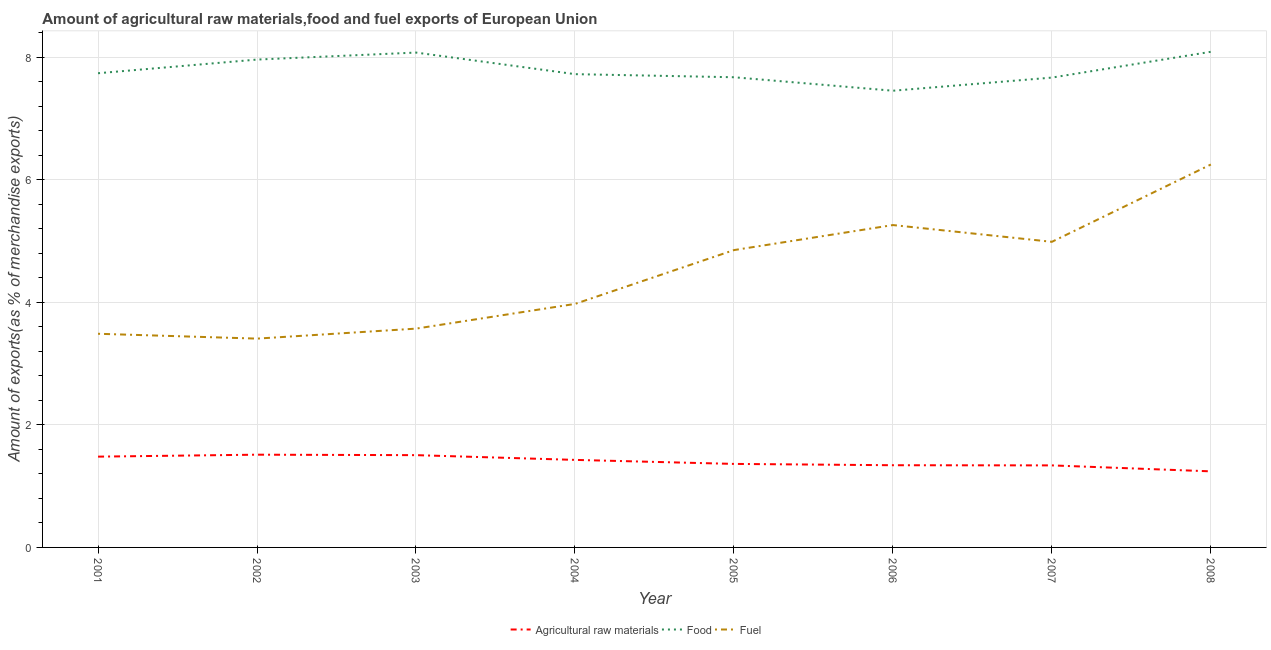Does the line corresponding to percentage of raw materials exports intersect with the line corresponding to percentage of fuel exports?
Give a very brief answer. No. Is the number of lines equal to the number of legend labels?
Offer a terse response. Yes. What is the percentage of fuel exports in 2002?
Provide a succinct answer. 3.41. Across all years, what is the maximum percentage of food exports?
Your response must be concise. 8.09. Across all years, what is the minimum percentage of food exports?
Make the answer very short. 7.45. In which year was the percentage of raw materials exports maximum?
Your answer should be compact. 2002. In which year was the percentage of raw materials exports minimum?
Ensure brevity in your answer.  2008. What is the total percentage of food exports in the graph?
Provide a succinct answer. 62.36. What is the difference between the percentage of raw materials exports in 2002 and that in 2003?
Make the answer very short. 0.01. What is the difference between the percentage of food exports in 2008 and the percentage of raw materials exports in 2006?
Offer a terse response. 6.74. What is the average percentage of raw materials exports per year?
Provide a short and direct response. 1.4. In the year 2006, what is the difference between the percentage of food exports and percentage of raw materials exports?
Your response must be concise. 6.11. In how many years, is the percentage of food exports greater than 3.2 %?
Offer a terse response. 8. What is the ratio of the percentage of fuel exports in 2002 to that in 2005?
Your answer should be very brief. 0.7. What is the difference between the highest and the second highest percentage of food exports?
Your answer should be very brief. 0.01. What is the difference between the highest and the lowest percentage of fuel exports?
Keep it short and to the point. 2.84. Does the percentage of food exports monotonically increase over the years?
Your answer should be very brief. No. Is the percentage of raw materials exports strictly less than the percentage of fuel exports over the years?
Offer a very short reply. Yes. Are the values on the major ticks of Y-axis written in scientific E-notation?
Offer a terse response. No. Does the graph contain grids?
Provide a succinct answer. Yes. Where does the legend appear in the graph?
Provide a succinct answer. Bottom center. How many legend labels are there?
Offer a terse response. 3. What is the title of the graph?
Offer a very short reply. Amount of agricultural raw materials,food and fuel exports of European Union. What is the label or title of the X-axis?
Your answer should be compact. Year. What is the label or title of the Y-axis?
Offer a very short reply. Amount of exports(as % of merchandise exports). What is the Amount of exports(as % of merchandise exports) of Agricultural raw materials in 2001?
Give a very brief answer. 1.48. What is the Amount of exports(as % of merchandise exports) of Food in 2001?
Make the answer very short. 7.74. What is the Amount of exports(as % of merchandise exports) in Fuel in 2001?
Offer a very short reply. 3.49. What is the Amount of exports(as % of merchandise exports) of Agricultural raw materials in 2002?
Give a very brief answer. 1.51. What is the Amount of exports(as % of merchandise exports) of Food in 2002?
Give a very brief answer. 7.96. What is the Amount of exports(as % of merchandise exports) of Fuel in 2002?
Your response must be concise. 3.41. What is the Amount of exports(as % of merchandise exports) in Agricultural raw materials in 2003?
Provide a succinct answer. 1.51. What is the Amount of exports(as % of merchandise exports) in Food in 2003?
Ensure brevity in your answer.  8.07. What is the Amount of exports(as % of merchandise exports) of Fuel in 2003?
Provide a succinct answer. 3.57. What is the Amount of exports(as % of merchandise exports) of Agricultural raw materials in 2004?
Keep it short and to the point. 1.43. What is the Amount of exports(as % of merchandise exports) of Food in 2004?
Keep it short and to the point. 7.72. What is the Amount of exports(as % of merchandise exports) in Fuel in 2004?
Offer a very short reply. 3.97. What is the Amount of exports(as % of merchandise exports) of Agricultural raw materials in 2005?
Give a very brief answer. 1.36. What is the Amount of exports(as % of merchandise exports) in Food in 2005?
Give a very brief answer. 7.67. What is the Amount of exports(as % of merchandise exports) in Fuel in 2005?
Offer a terse response. 4.85. What is the Amount of exports(as % of merchandise exports) of Agricultural raw materials in 2006?
Provide a succinct answer. 1.34. What is the Amount of exports(as % of merchandise exports) in Food in 2006?
Make the answer very short. 7.45. What is the Amount of exports(as % of merchandise exports) in Fuel in 2006?
Offer a very short reply. 5.26. What is the Amount of exports(as % of merchandise exports) in Agricultural raw materials in 2007?
Provide a short and direct response. 1.34. What is the Amount of exports(as % of merchandise exports) of Food in 2007?
Give a very brief answer. 7.66. What is the Amount of exports(as % of merchandise exports) in Fuel in 2007?
Offer a terse response. 4.99. What is the Amount of exports(as % of merchandise exports) of Agricultural raw materials in 2008?
Your response must be concise. 1.24. What is the Amount of exports(as % of merchandise exports) of Food in 2008?
Your response must be concise. 8.09. What is the Amount of exports(as % of merchandise exports) of Fuel in 2008?
Ensure brevity in your answer.  6.25. Across all years, what is the maximum Amount of exports(as % of merchandise exports) of Agricultural raw materials?
Your response must be concise. 1.51. Across all years, what is the maximum Amount of exports(as % of merchandise exports) of Food?
Provide a short and direct response. 8.09. Across all years, what is the maximum Amount of exports(as % of merchandise exports) of Fuel?
Offer a terse response. 6.25. Across all years, what is the minimum Amount of exports(as % of merchandise exports) of Agricultural raw materials?
Provide a short and direct response. 1.24. Across all years, what is the minimum Amount of exports(as % of merchandise exports) of Food?
Keep it short and to the point. 7.45. Across all years, what is the minimum Amount of exports(as % of merchandise exports) in Fuel?
Ensure brevity in your answer.  3.41. What is the total Amount of exports(as % of merchandise exports) of Agricultural raw materials in the graph?
Your answer should be compact. 11.21. What is the total Amount of exports(as % of merchandise exports) in Food in the graph?
Provide a succinct answer. 62.36. What is the total Amount of exports(as % of merchandise exports) in Fuel in the graph?
Give a very brief answer. 35.78. What is the difference between the Amount of exports(as % of merchandise exports) of Agricultural raw materials in 2001 and that in 2002?
Provide a succinct answer. -0.03. What is the difference between the Amount of exports(as % of merchandise exports) in Food in 2001 and that in 2002?
Offer a very short reply. -0.22. What is the difference between the Amount of exports(as % of merchandise exports) of Fuel in 2001 and that in 2002?
Provide a succinct answer. 0.08. What is the difference between the Amount of exports(as % of merchandise exports) of Agricultural raw materials in 2001 and that in 2003?
Offer a very short reply. -0.02. What is the difference between the Amount of exports(as % of merchandise exports) in Food in 2001 and that in 2003?
Offer a very short reply. -0.34. What is the difference between the Amount of exports(as % of merchandise exports) of Fuel in 2001 and that in 2003?
Keep it short and to the point. -0.08. What is the difference between the Amount of exports(as % of merchandise exports) of Agricultural raw materials in 2001 and that in 2004?
Keep it short and to the point. 0.05. What is the difference between the Amount of exports(as % of merchandise exports) in Food in 2001 and that in 2004?
Your answer should be compact. 0.01. What is the difference between the Amount of exports(as % of merchandise exports) in Fuel in 2001 and that in 2004?
Ensure brevity in your answer.  -0.49. What is the difference between the Amount of exports(as % of merchandise exports) in Agricultural raw materials in 2001 and that in 2005?
Provide a short and direct response. 0.12. What is the difference between the Amount of exports(as % of merchandise exports) in Food in 2001 and that in 2005?
Provide a succinct answer. 0.07. What is the difference between the Amount of exports(as % of merchandise exports) in Fuel in 2001 and that in 2005?
Offer a very short reply. -1.36. What is the difference between the Amount of exports(as % of merchandise exports) of Agricultural raw materials in 2001 and that in 2006?
Provide a short and direct response. 0.14. What is the difference between the Amount of exports(as % of merchandise exports) of Food in 2001 and that in 2006?
Provide a succinct answer. 0.29. What is the difference between the Amount of exports(as % of merchandise exports) in Fuel in 2001 and that in 2006?
Offer a terse response. -1.77. What is the difference between the Amount of exports(as % of merchandise exports) in Agricultural raw materials in 2001 and that in 2007?
Offer a very short reply. 0.14. What is the difference between the Amount of exports(as % of merchandise exports) in Food in 2001 and that in 2007?
Offer a terse response. 0.07. What is the difference between the Amount of exports(as % of merchandise exports) in Fuel in 2001 and that in 2007?
Provide a succinct answer. -1.5. What is the difference between the Amount of exports(as % of merchandise exports) in Agricultural raw materials in 2001 and that in 2008?
Offer a terse response. 0.24. What is the difference between the Amount of exports(as % of merchandise exports) in Food in 2001 and that in 2008?
Offer a terse response. -0.35. What is the difference between the Amount of exports(as % of merchandise exports) in Fuel in 2001 and that in 2008?
Your response must be concise. -2.76. What is the difference between the Amount of exports(as % of merchandise exports) in Agricultural raw materials in 2002 and that in 2003?
Ensure brevity in your answer.  0.01. What is the difference between the Amount of exports(as % of merchandise exports) of Food in 2002 and that in 2003?
Your answer should be very brief. -0.11. What is the difference between the Amount of exports(as % of merchandise exports) of Fuel in 2002 and that in 2003?
Your answer should be very brief. -0.16. What is the difference between the Amount of exports(as % of merchandise exports) of Agricultural raw materials in 2002 and that in 2004?
Ensure brevity in your answer.  0.08. What is the difference between the Amount of exports(as % of merchandise exports) in Food in 2002 and that in 2004?
Offer a terse response. 0.24. What is the difference between the Amount of exports(as % of merchandise exports) in Fuel in 2002 and that in 2004?
Your response must be concise. -0.57. What is the difference between the Amount of exports(as % of merchandise exports) of Agricultural raw materials in 2002 and that in 2005?
Make the answer very short. 0.15. What is the difference between the Amount of exports(as % of merchandise exports) in Food in 2002 and that in 2005?
Your answer should be very brief. 0.29. What is the difference between the Amount of exports(as % of merchandise exports) in Fuel in 2002 and that in 2005?
Your answer should be very brief. -1.44. What is the difference between the Amount of exports(as % of merchandise exports) in Agricultural raw materials in 2002 and that in 2006?
Your response must be concise. 0.17. What is the difference between the Amount of exports(as % of merchandise exports) in Food in 2002 and that in 2006?
Your response must be concise. 0.51. What is the difference between the Amount of exports(as % of merchandise exports) of Fuel in 2002 and that in 2006?
Your response must be concise. -1.85. What is the difference between the Amount of exports(as % of merchandise exports) in Agricultural raw materials in 2002 and that in 2007?
Your response must be concise. 0.17. What is the difference between the Amount of exports(as % of merchandise exports) in Food in 2002 and that in 2007?
Provide a short and direct response. 0.29. What is the difference between the Amount of exports(as % of merchandise exports) of Fuel in 2002 and that in 2007?
Offer a terse response. -1.58. What is the difference between the Amount of exports(as % of merchandise exports) in Agricultural raw materials in 2002 and that in 2008?
Your response must be concise. 0.27. What is the difference between the Amount of exports(as % of merchandise exports) of Food in 2002 and that in 2008?
Make the answer very short. -0.13. What is the difference between the Amount of exports(as % of merchandise exports) of Fuel in 2002 and that in 2008?
Give a very brief answer. -2.84. What is the difference between the Amount of exports(as % of merchandise exports) in Agricultural raw materials in 2003 and that in 2004?
Your response must be concise. 0.08. What is the difference between the Amount of exports(as % of merchandise exports) in Food in 2003 and that in 2004?
Offer a terse response. 0.35. What is the difference between the Amount of exports(as % of merchandise exports) in Fuel in 2003 and that in 2004?
Offer a very short reply. -0.4. What is the difference between the Amount of exports(as % of merchandise exports) of Agricultural raw materials in 2003 and that in 2005?
Ensure brevity in your answer.  0.14. What is the difference between the Amount of exports(as % of merchandise exports) of Food in 2003 and that in 2005?
Your response must be concise. 0.4. What is the difference between the Amount of exports(as % of merchandise exports) in Fuel in 2003 and that in 2005?
Make the answer very short. -1.28. What is the difference between the Amount of exports(as % of merchandise exports) in Agricultural raw materials in 2003 and that in 2006?
Your response must be concise. 0.16. What is the difference between the Amount of exports(as % of merchandise exports) in Food in 2003 and that in 2006?
Provide a succinct answer. 0.62. What is the difference between the Amount of exports(as % of merchandise exports) in Fuel in 2003 and that in 2006?
Offer a very short reply. -1.69. What is the difference between the Amount of exports(as % of merchandise exports) in Agricultural raw materials in 2003 and that in 2007?
Provide a short and direct response. 0.17. What is the difference between the Amount of exports(as % of merchandise exports) of Food in 2003 and that in 2007?
Offer a terse response. 0.41. What is the difference between the Amount of exports(as % of merchandise exports) in Fuel in 2003 and that in 2007?
Provide a succinct answer. -1.42. What is the difference between the Amount of exports(as % of merchandise exports) of Agricultural raw materials in 2003 and that in 2008?
Make the answer very short. 0.26. What is the difference between the Amount of exports(as % of merchandise exports) in Food in 2003 and that in 2008?
Ensure brevity in your answer.  -0.01. What is the difference between the Amount of exports(as % of merchandise exports) of Fuel in 2003 and that in 2008?
Your answer should be compact. -2.68. What is the difference between the Amount of exports(as % of merchandise exports) of Agricultural raw materials in 2004 and that in 2005?
Give a very brief answer. 0.07. What is the difference between the Amount of exports(as % of merchandise exports) of Food in 2004 and that in 2005?
Give a very brief answer. 0.05. What is the difference between the Amount of exports(as % of merchandise exports) of Fuel in 2004 and that in 2005?
Offer a very short reply. -0.88. What is the difference between the Amount of exports(as % of merchandise exports) in Agricultural raw materials in 2004 and that in 2006?
Your response must be concise. 0.09. What is the difference between the Amount of exports(as % of merchandise exports) in Food in 2004 and that in 2006?
Make the answer very short. 0.27. What is the difference between the Amount of exports(as % of merchandise exports) of Fuel in 2004 and that in 2006?
Offer a terse response. -1.29. What is the difference between the Amount of exports(as % of merchandise exports) in Agricultural raw materials in 2004 and that in 2007?
Ensure brevity in your answer.  0.09. What is the difference between the Amount of exports(as % of merchandise exports) in Food in 2004 and that in 2007?
Offer a terse response. 0.06. What is the difference between the Amount of exports(as % of merchandise exports) in Fuel in 2004 and that in 2007?
Ensure brevity in your answer.  -1.01. What is the difference between the Amount of exports(as % of merchandise exports) of Agricultural raw materials in 2004 and that in 2008?
Make the answer very short. 0.19. What is the difference between the Amount of exports(as % of merchandise exports) of Food in 2004 and that in 2008?
Make the answer very short. -0.36. What is the difference between the Amount of exports(as % of merchandise exports) of Fuel in 2004 and that in 2008?
Your answer should be very brief. -2.27. What is the difference between the Amount of exports(as % of merchandise exports) in Agricultural raw materials in 2005 and that in 2006?
Ensure brevity in your answer.  0.02. What is the difference between the Amount of exports(as % of merchandise exports) of Food in 2005 and that in 2006?
Keep it short and to the point. 0.22. What is the difference between the Amount of exports(as % of merchandise exports) of Fuel in 2005 and that in 2006?
Your answer should be very brief. -0.41. What is the difference between the Amount of exports(as % of merchandise exports) in Agricultural raw materials in 2005 and that in 2007?
Ensure brevity in your answer.  0.02. What is the difference between the Amount of exports(as % of merchandise exports) of Food in 2005 and that in 2007?
Give a very brief answer. 0.01. What is the difference between the Amount of exports(as % of merchandise exports) in Fuel in 2005 and that in 2007?
Offer a very short reply. -0.14. What is the difference between the Amount of exports(as % of merchandise exports) in Agricultural raw materials in 2005 and that in 2008?
Offer a terse response. 0.12. What is the difference between the Amount of exports(as % of merchandise exports) in Food in 2005 and that in 2008?
Make the answer very short. -0.42. What is the difference between the Amount of exports(as % of merchandise exports) of Fuel in 2005 and that in 2008?
Your answer should be very brief. -1.4. What is the difference between the Amount of exports(as % of merchandise exports) of Agricultural raw materials in 2006 and that in 2007?
Offer a very short reply. 0. What is the difference between the Amount of exports(as % of merchandise exports) in Food in 2006 and that in 2007?
Provide a short and direct response. -0.21. What is the difference between the Amount of exports(as % of merchandise exports) of Fuel in 2006 and that in 2007?
Your response must be concise. 0.27. What is the difference between the Amount of exports(as % of merchandise exports) in Agricultural raw materials in 2006 and that in 2008?
Make the answer very short. 0.1. What is the difference between the Amount of exports(as % of merchandise exports) of Food in 2006 and that in 2008?
Your response must be concise. -0.64. What is the difference between the Amount of exports(as % of merchandise exports) in Fuel in 2006 and that in 2008?
Provide a succinct answer. -0.99. What is the difference between the Amount of exports(as % of merchandise exports) in Agricultural raw materials in 2007 and that in 2008?
Your answer should be very brief. 0.1. What is the difference between the Amount of exports(as % of merchandise exports) in Food in 2007 and that in 2008?
Your response must be concise. -0.42. What is the difference between the Amount of exports(as % of merchandise exports) of Fuel in 2007 and that in 2008?
Give a very brief answer. -1.26. What is the difference between the Amount of exports(as % of merchandise exports) in Agricultural raw materials in 2001 and the Amount of exports(as % of merchandise exports) in Food in 2002?
Your answer should be very brief. -6.48. What is the difference between the Amount of exports(as % of merchandise exports) of Agricultural raw materials in 2001 and the Amount of exports(as % of merchandise exports) of Fuel in 2002?
Make the answer very short. -1.93. What is the difference between the Amount of exports(as % of merchandise exports) in Food in 2001 and the Amount of exports(as % of merchandise exports) in Fuel in 2002?
Offer a terse response. 4.33. What is the difference between the Amount of exports(as % of merchandise exports) of Agricultural raw materials in 2001 and the Amount of exports(as % of merchandise exports) of Food in 2003?
Give a very brief answer. -6.59. What is the difference between the Amount of exports(as % of merchandise exports) of Agricultural raw materials in 2001 and the Amount of exports(as % of merchandise exports) of Fuel in 2003?
Make the answer very short. -2.09. What is the difference between the Amount of exports(as % of merchandise exports) of Food in 2001 and the Amount of exports(as % of merchandise exports) of Fuel in 2003?
Ensure brevity in your answer.  4.17. What is the difference between the Amount of exports(as % of merchandise exports) of Agricultural raw materials in 2001 and the Amount of exports(as % of merchandise exports) of Food in 2004?
Provide a succinct answer. -6.24. What is the difference between the Amount of exports(as % of merchandise exports) in Agricultural raw materials in 2001 and the Amount of exports(as % of merchandise exports) in Fuel in 2004?
Ensure brevity in your answer.  -2.49. What is the difference between the Amount of exports(as % of merchandise exports) of Food in 2001 and the Amount of exports(as % of merchandise exports) of Fuel in 2004?
Ensure brevity in your answer.  3.76. What is the difference between the Amount of exports(as % of merchandise exports) in Agricultural raw materials in 2001 and the Amount of exports(as % of merchandise exports) in Food in 2005?
Make the answer very short. -6.19. What is the difference between the Amount of exports(as % of merchandise exports) in Agricultural raw materials in 2001 and the Amount of exports(as % of merchandise exports) in Fuel in 2005?
Your answer should be compact. -3.37. What is the difference between the Amount of exports(as % of merchandise exports) in Food in 2001 and the Amount of exports(as % of merchandise exports) in Fuel in 2005?
Offer a terse response. 2.89. What is the difference between the Amount of exports(as % of merchandise exports) in Agricultural raw materials in 2001 and the Amount of exports(as % of merchandise exports) in Food in 2006?
Keep it short and to the point. -5.97. What is the difference between the Amount of exports(as % of merchandise exports) of Agricultural raw materials in 2001 and the Amount of exports(as % of merchandise exports) of Fuel in 2006?
Your answer should be very brief. -3.78. What is the difference between the Amount of exports(as % of merchandise exports) of Food in 2001 and the Amount of exports(as % of merchandise exports) of Fuel in 2006?
Your answer should be compact. 2.48. What is the difference between the Amount of exports(as % of merchandise exports) of Agricultural raw materials in 2001 and the Amount of exports(as % of merchandise exports) of Food in 2007?
Your answer should be very brief. -6.18. What is the difference between the Amount of exports(as % of merchandise exports) of Agricultural raw materials in 2001 and the Amount of exports(as % of merchandise exports) of Fuel in 2007?
Ensure brevity in your answer.  -3.5. What is the difference between the Amount of exports(as % of merchandise exports) in Food in 2001 and the Amount of exports(as % of merchandise exports) in Fuel in 2007?
Your answer should be compact. 2.75. What is the difference between the Amount of exports(as % of merchandise exports) in Agricultural raw materials in 2001 and the Amount of exports(as % of merchandise exports) in Food in 2008?
Give a very brief answer. -6.6. What is the difference between the Amount of exports(as % of merchandise exports) in Agricultural raw materials in 2001 and the Amount of exports(as % of merchandise exports) in Fuel in 2008?
Provide a succinct answer. -4.77. What is the difference between the Amount of exports(as % of merchandise exports) in Food in 2001 and the Amount of exports(as % of merchandise exports) in Fuel in 2008?
Provide a short and direct response. 1.49. What is the difference between the Amount of exports(as % of merchandise exports) of Agricultural raw materials in 2002 and the Amount of exports(as % of merchandise exports) of Food in 2003?
Ensure brevity in your answer.  -6.56. What is the difference between the Amount of exports(as % of merchandise exports) in Agricultural raw materials in 2002 and the Amount of exports(as % of merchandise exports) in Fuel in 2003?
Your response must be concise. -2.06. What is the difference between the Amount of exports(as % of merchandise exports) of Food in 2002 and the Amount of exports(as % of merchandise exports) of Fuel in 2003?
Offer a very short reply. 4.39. What is the difference between the Amount of exports(as % of merchandise exports) in Agricultural raw materials in 2002 and the Amount of exports(as % of merchandise exports) in Food in 2004?
Give a very brief answer. -6.21. What is the difference between the Amount of exports(as % of merchandise exports) of Agricultural raw materials in 2002 and the Amount of exports(as % of merchandise exports) of Fuel in 2004?
Your answer should be compact. -2.46. What is the difference between the Amount of exports(as % of merchandise exports) of Food in 2002 and the Amount of exports(as % of merchandise exports) of Fuel in 2004?
Provide a succinct answer. 3.99. What is the difference between the Amount of exports(as % of merchandise exports) in Agricultural raw materials in 2002 and the Amount of exports(as % of merchandise exports) in Food in 2005?
Your answer should be very brief. -6.16. What is the difference between the Amount of exports(as % of merchandise exports) in Agricultural raw materials in 2002 and the Amount of exports(as % of merchandise exports) in Fuel in 2005?
Offer a very short reply. -3.34. What is the difference between the Amount of exports(as % of merchandise exports) in Food in 2002 and the Amount of exports(as % of merchandise exports) in Fuel in 2005?
Make the answer very short. 3.11. What is the difference between the Amount of exports(as % of merchandise exports) of Agricultural raw materials in 2002 and the Amount of exports(as % of merchandise exports) of Food in 2006?
Your answer should be compact. -5.94. What is the difference between the Amount of exports(as % of merchandise exports) in Agricultural raw materials in 2002 and the Amount of exports(as % of merchandise exports) in Fuel in 2006?
Keep it short and to the point. -3.75. What is the difference between the Amount of exports(as % of merchandise exports) in Food in 2002 and the Amount of exports(as % of merchandise exports) in Fuel in 2006?
Your response must be concise. 2.7. What is the difference between the Amount of exports(as % of merchandise exports) of Agricultural raw materials in 2002 and the Amount of exports(as % of merchandise exports) of Food in 2007?
Provide a succinct answer. -6.15. What is the difference between the Amount of exports(as % of merchandise exports) in Agricultural raw materials in 2002 and the Amount of exports(as % of merchandise exports) in Fuel in 2007?
Your answer should be compact. -3.47. What is the difference between the Amount of exports(as % of merchandise exports) of Food in 2002 and the Amount of exports(as % of merchandise exports) of Fuel in 2007?
Keep it short and to the point. 2.97. What is the difference between the Amount of exports(as % of merchandise exports) of Agricultural raw materials in 2002 and the Amount of exports(as % of merchandise exports) of Food in 2008?
Keep it short and to the point. -6.57. What is the difference between the Amount of exports(as % of merchandise exports) in Agricultural raw materials in 2002 and the Amount of exports(as % of merchandise exports) in Fuel in 2008?
Your response must be concise. -4.73. What is the difference between the Amount of exports(as % of merchandise exports) in Food in 2002 and the Amount of exports(as % of merchandise exports) in Fuel in 2008?
Keep it short and to the point. 1.71. What is the difference between the Amount of exports(as % of merchandise exports) in Agricultural raw materials in 2003 and the Amount of exports(as % of merchandise exports) in Food in 2004?
Provide a short and direct response. -6.22. What is the difference between the Amount of exports(as % of merchandise exports) in Agricultural raw materials in 2003 and the Amount of exports(as % of merchandise exports) in Fuel in 2004?
Keep it short and to the point. -2.47. What is the difference between the Amount of exports(as % of merchandise exports) of Food in 2003 and the Amount of exports(as % of merchandise exports) of Fuel in 2004?
Give a very brief answer. 4.1. What is the difference between the Amount of exports(as % of merchandise exports) of Agricultural raw materials in 2003 and the Amount of exports(as % of merchandise exports) of Food in 2005?
Provide a short and direct response. -6.17. What is the difference between the Amount of exports(as % of merchandise exports) of Agricultural raw materials in 2003 and the Amount of exports(as % of merchandise exports) of Fuel in 2005?
Make the answer very short. -3.35. What is the difference between the Amount of exports(as % of merchandise exports) of Food in 2003 and the Amount of exports(as % of merchandise exports) of Fuel in 2005?
Provide a short and direct response. 3.22. What is the difference between the Amount of exports(as % of merchandise exports) in Agricultural raw materials in 2003 and the Amount of exports(as % of merchandise exports) in Food in 2006?
Ensure brevity in your answer.  -5.95. What is the difference between the Amount of exports(as % of merchandise exports) in Agricultural raw materials in 2003 and the Amount of exports(as % of merchandise exports) in Fuel in 2006?
Give a very brief answer. -3.75. What is the difference between the Amount of exports(as % of merchandise exports) of Food in 2003 and the Amount of exports(as % of merchandise exports) of Fuel in 2006?
Keep it short and to the point. 2.81. What is the difference between the Amount of exports(as % of merchandise exports) in Agricultural raw materials in 2003 and the Amount of exports(as % of merchandise exports) in Food in 2007?
Give a very brief answer. -6.16. What is the difference between the Amount of exports(as % of merchandise exports) of Agricultural raw materials in 2003 and the Amount of exports(as % of merchandise exports) of Fuel in 2007?
Your answer should be compact. -3.48. What is the difference between the Amount of exports(as % of merchandise exports) in Food in 2003 and the Amount of exports(as % of merchandise exports) in Fuel in 2007?
Ensure brevity in your answer.  3.09. What is the difference between the Amount of exports(as % of merchandise exports) of Agricultural raw materials in 2003 and the Amount of exports(as % of merchandise exports) of Food in 2008?
Keep it short and to the point. -6.58. What is the difference between the Amount of exports(as % of merchandise exports) in Agricultural raw materials in 2003 and the Amount of exports(as % of merchandise exports) in Fuel in 2008?
Your answer should be compact. -4.74. What is the difference between the Amount of exports(as % of merchandise exports) in Food in 2003 and the Amount of exports(as % of merchandise exports) in Fuel in 2008?
Offer a terse response. 1.83. What is the difference between the Amount of exports(as % of merchandise exports) of Agricultural raw materials in 2004 and the Amount of exports(as % of merchandise exports) of Food in 2005?
Your answer should be compact. -6.24. What is the difference between the Amount of exports(as % of merchandise exports) in Agricultural raw materials in 2004 and the Amount of exports(as % of merchandise exports) in Fuel in 2005?
Make the answer very short. -3.42. What is the difference between the Amount of exports(as % of merchandise exports) in Food in 2004 and the Amount of exports(as % of merchandise exports) in Fuel in 2005?
Provide a succinct answer. 2.87. What is the difference between the Amount of exports(as % of merchandise exports) in Agricultural raw materials in 2004 and the Amount of exports(as % of merchandise exports) in Food in 2006?
Your response must be concise. -6.02. What is the difference between the Amount of exports(as % of merchandise exports) in Agricultural raw materials in 2004 and the Amount of exports(as % of merchandise exports) in Fuel in 2006?
Your answer should be compact. -3.83. What is the difference between the Amount of exports(as % of merchandise exports) of Food in 2004 and the Amount of exports(as % of merchandise exports) of Fuel in 2006?
Offer a very short reply. 2.46. What is the difference between the Amount of exports(as % of merchandise exports) in Agricultural raw materials in 2004 and the Amount of exports(as % of merchandise exports) in Food in 2007?
Your answer should be compact. -6.24. What is the difference between the Amount of exports(as % of merchandise exports) in Agricultural raw materials in 2004 and the Amount of exports(as % of merchandise exports) in Fuel in 2007?
Provide a short and direct response. -3.56. What is the difference between the Amount of exports(as % of merchandise exports) in Food in 2004 and the Amount of exports(as % of merchandise exports) in Fuel in 2007?
Provide a short and direct response. 2.74. What is the difference between the Amount of exports(as % of merchandise exports) of Agricultural raw materials in 2004 and the Amount of exports(as % of merchandise exports) of Food in 2008?
Offer a terse response. -6.66. What is the difference between the Amount of exports(as % of merchandise exports) in Agricultural raw materials in 2004 and the Amount of exports(as % of merchandise exports) in Fuel in 2008?
Your answer should be very brief. -4.82. What is the difference between the Amount of exports(as % of merchandise exports) of Food in 2004 and the Amount of exports(as % of merchandise exports) of Fuel in 2008?
Provide a short and direct response. 1.47. What is the difference between the Amount of exports(as % of merchandise exports) of Agricultural raw materials in 2005 and the Amount of exports(as % of merchandise exports) of Food in 2006?
Your answer should be very brief. -6.09. What is the difference between the Amount of exports(as % of merchandise exports) of Agricultural raw materials in 2005 and the Amount of exports(as % of merchandise exports) of Fuel in 2006?
Provide a succinct answer. -3.9. What is the difference between the Amount of exports(as % of merchandise exports) in Food in 2005 and the Amount of exports(as % of merchandise exports) in Fuel in 2006?
Your answer should be very brief. 2.41. What is the difference between the Amount of exports(as % of merchandise exports) of Agricultural raw materials in 2005 and the Amount of exports(as % of merchandise exports) of Food in 2007?
Offer a terse response. -6.3. What is the difference between the Amount of exports(as % of merchandise exports) of Agricultural raw materials in 2005 and the Amount of exports(as % of merchandise exports) of Fuel in 2007?
Your answer should be very brief. -3.62. What is the difference between the Amount of exports(as % of merchandise exports) of Food in 2005 and the Amount of exports(as % of merchandise exports) of Fuel in 2007?
Your answer should be compact. 2.68. What is the difference between the Amount of exports(as % of merchandise exports) of Agricultural raw materials in 2005 and the Amount of exports(as % of merchandise exports) of Food in 2008?
Give a very brief answer. -6.72. What is the difference between the Amount of exports(as % of merchandise exports) in Agricultural raw materials in 2005 and the Amount of exports(as % of merchandise exports) in Fuel in 2008?
Offer a very short reply. -4.88. What is the difference between the Amount of exports(as % of merchandise exports) of Food in 2005 and the Amount of exports(as % of merchandise exports) of Fuel in 2008?
Your response must be concise. 1.42. What is the difference between the Amount of exports(as % of merchandise exports) of Agricultural raw materials in 2006 and the Amount of exports(as % of merchandise exports) of Food in 2007?
Make the answer very short. -6.32. What is the difference between the Amount of exports(as % of merchandise exports) of Agricultural raw materials in 2006 and the Amount of exports(as % of merchandise exports) of Fuel in 2007?
Provide a succinct answer. -3.64. What is the difference between the Amount of exports(as % of merchandise exports) of Food in 2006 and the Amount of exports(as % of merchandise exports) of Fuel in 2007?
Give a very brief answer. 2.46. What is the difference between the Amount of exports(as % of merchandise exports) of Agricultural raw materials in 2006 and the Amount of exports(as % of merchandise exports) of Food in 2008?
Offer a terse response. -6.74. What is the difference between the Amount of exports(as % of merchandise exports) in Agricultural raw materials in 2006 and the Amount of exports(as % of merchandise exports) in Fuel in 2008?
Give a very brief answer. -4.91. What is the difference between the Amount of exports(as % of merchandise exports) of Food in 2006 and the Amount of exports(as % of merchandise exports) of Fuel in 2008?
Provide a succinct answer. 1.2. What is the difference between the Amount of exports(as % of merchandise exports) of Agricultural raw materials in 2007 and the Amount of exports(as % of merchandise exports) of Food in 2008?
Your answer should be compact. -6.75. What is the difference between the Amount of exports(as % of merchandise exports) of Agricultural raw materials in 2007 and the Amount of exports(as % of merchandise exports) of Fuel in 2008?
Provide a succinct answer. -4.91. What is the difference between the Amount of exports(as % of merchandise exports) in Food in 2007 and the Amount of exports(as % of merchandise exports) in Fuel in 2008?
Offer a very short reply. 1.42. What is the average Amount of exports(as % of merchandise exports) in Agricultural raw materials per year?
Your answer should be very brief. 1.4. What is the average Amount of exports(as % of merchandise exports) of Food per year?
Keep it short and to the point. 7.8. What is the average Amount of exports(as % of merchandise exports) in Fuel per year?
Keep it short and to the point. 4.47. In the year 2001, what is the difference between the Amount of exports(as % of merchandise exports) of Agricultural raw materials and Amount of exports(as % of merchandise exports) of Food?
Keep it short and to the point. -6.25. In the year 2001, what is the difference between the Amount of exports(as % of merchandise exports) of Agricultural raw materials and Amount of exports(as % of merchandise exports) of Fuel?
Offer a very short reply. -2. In the year 2001, what is the difference between the Amount of exports(as % of merchandise exports) of Food and Amount of exports(as % of merchandise exports) of Fuel?
Give a very brief answer. 4.25. In the year 2002, what is the difference between the Amount of exports(as % of merchandise exports) in Agricultural raw materials and Amount of exports(as % of merchandise exports) in Food?
Give a very brief answer. -6.45. In the year 2002, what is the difference between the Amount of exports(as % of merchandise exports) in Agricultural raw materials and Amount of exports(as % of merchandise exports) in Fuel?
Your response must be concise. -1.89. In the year 2002, what is the difference between the Amount of exports(as % of merchandise exports) in Food and Amount of exports(as % of merchandise exports) in Fuel?
Provide a short and direct response. 4.55. In the year 2003, what is the difference between the Amount of exports(as % of merchandise exports) in Agricultural raw materials and Amount of exports(as % of merchandise exports) in Food?
Keep it short and to the point. -6.57. In the year 2003, what is the difference between the Amount of exports(as % of merchandise exports) of Agricultural raw materials and Amount of exports(as % of merchandise exports) of Fuel?
Your answer should be compact. -2.06. In the year 2003, what is the difference between the Amount of exports(as % of merchandise exports) in Food and Amount of exports(as % of merchandise exports) in Fuel?
Provide a short and direct response. 4.5. In the year 2004, what is the difference between the Amount of exports(as % of merchandise exports) of Agricultural raw materials and Amount of exports(as % of merchandise exports) of Food?
Your answer should be compact. -6.29. In the year 2004, what is the difference between the Amount of exports(as % of merchandise exports) of Agricultural raw materials and Amount of exports(as % of merchandise exports) of Fuel?
Provide a short and direct response. -2.54. In the year 2004, what is the difference between the Amount of exports(as % of merchandise exports) of Food and Amount of exports(as % of merchandise exports) of Fuel?
Offer a terse response. 3.75. In the year 2005, what is the difference between the Amount of exports(as % of merchandise exports) in Agricultural raw materials and Amount of exports(as % of merchandise exports) in Food?
Keep it short and to the point. -6.31. In the year 2005, what is the difference between the Amount of exports(as % of merchandise exports) of Agricultural raw materials and Amount of exports(as % of merchandise exports) of Fuel?
Keep it short and to the point. -3.49. In the year 2005, what is the difference between the Amount of exports(as % of merchandise exports) of Food and Amount of exports(as % of merchandise exports) of Fuel?
Offer a very short reply. 2.82. In the year 2006, what is the difference between the Amount of exports(as % of merchandise exports) of Agricultural raw materials and Amount of exports(as % of merchandise exports) of Food?
Provide a succinct answer. -6.11. In the year 2006, what is the difference between the Amount of exports(as % of merchandise exports) in Agricultural raw materials and Amount of exports(as % of merchandise exports) in Fuel?
Provide a short and direct response. -3.92. In the year 2006, what is the difference between the Amount of exports(as % of merchandise exports) in Food and Amount of exports(as % of merchandise exports) in Fuel?
Provide a succinct answer. 2.19. In the year 2007, what is the difference between the Amount of exports(as % of merchandise exports) in Agricultural raw materials and Amount of exports(as % of merchandise exports) in Food?
Your answer should be very brief. -6.33. In the year 2007, what is the difference between the Amount of exports(as % of merchandise exports) of Agricultural raw materials and Amount of exports(as % of merchandise exports) of Fuel?
Ensure brevity in your answer.  -3.65. In the year 2007, what is the difference between the Amount of exports(as % of merchandise exports) in Food and Amount of exports(as % of merchandise exports) in Fuel?
Offer a very short reply. 2.68. In the year 2008, what is the difference between the Amount of exports(as % of merchandise exports) of Agricultural raw materials and Amount of exports(as % of merchandise exports) of Food?
Your answer should be very brief. -6.84. In the year 2008, what is the difference between the Amount of exports(as % of merchandise exports) in Agricultural raw materials and Amount of exports(as % of merchandise exports) in Fuel?
Keep it short and to the point. -5.01. In the year 2008, what is the difference between the Amount of exports(as % of merchandise exports) of Food and Amount of exports(as % of merchandise exports) of Fuel?
Offer a terse response. 1.84. What is the ratio of the Amount of exports(as % of merchandise exports) in Agricultural raw materials in 2001 to that in 2002?
Offer a terse response. 0.98. What is the ratio of the Amount of exports(as % of merchandise exports) of Fuel in 2001 to that in 2002?
Keep it short and to the point. 1.02. What is the ratio of the Amount of exports(as % of merchandise exports) of Agricultural raw materials in 2001 to that in 2003?
Ensure brevity in your answer.  0.98. What is the ratio of the Amount of exports(as % of merchandise exports) in Food in 2001 to that in 2003?
Offer a very short reply. 0.96. What is the ratio of the Amount of exports(as % of merchandise exports) in Fuel in 2001 to that in 2003?
Your answer should be compact. 0.98. What is the ratio of the Amount of exports(as % of merchandise exports) in Agricultural raw materials in 2001 to that in 2004?
Your answer should be very brief. 1.04. What is the ratio of the Amount of exports(as % of merchandise exports) in Fuel in 2001 to that in 2004?
Ensure brevity in your answer.  0.88. What is the ratio of the Amount of exports(as % of merchandise exports) of Agricultural raw materials in 2001 to that in 2005?
Provide a succinct answer. 1.09. What is the ratio of the Amount of exports(as % of merchandise exports) in Food in 2001 to that in 2005?
Provide a short and direct response. 1.01. What is the ratio of the Amount of exports(as % of merchandise exports) in Fuel in 2001 to that in 2005?
Your answer should be very brief. 0.72. What is the ratio of the Amount of exports(as % of merchandise exports) of Agricultural raw materials in 2001 to that in 2006?
Your response must be concise. 1.1. What is the ratio of the Amount of exports(as % of merchandise exports) of Food in 2001 to that in 2006?
Offer a very short reply. 1.04. What is the ratio of the Amount of exports(as % of merchandise exports) in Fuel in 2001 to that in 2006?
Provide a succinct answer. 0.66. What is the ratio of the Amount of exports(as % of merchandise exports) of Agricultural raw materials in 2001 to that in 2007?
Ensure brevity in your answer.  1.11. What is the ratio of the Amount of exports(as % of merchandise exports) in Food in 2001 to that in 2007?
Your answer should be very brief. 1.01. What is the ratio of the Amount of exports(as % of merchandise exports) of Fuel in 2001 to that in 2007?
Your answer should be compact. 0.7. What is the ratio of the Amount of exports(as % of merchandise exports) in Agricultural raw materials in 2001 to that in 2008?
Offer a very short reply. 1.19. What is the ratio of the Amount of exports(as % of merchandise exports) of Food in 2001 to that in 2008?
Your answer should be very brief. 0.96. What is the ratio of the Amount of exports(as % of merchandise exports) in Fuel in 2001 to that in 2008?
Provide a succinct answer. 0.56. What is the ratio of the Amount of exports(as % of merchandise exports) of Agricultural raw materials in 2002 to that in 2003?
Offer a very short reply. 1. What is the ratio of the Amount of exports(as % of merchandise exports) in Food in 2002 to that in 2003?
Give a very brief answer. 0.99. What is the ratio of the Amount of exports(as % of merchandise exports) of Fuel in 2002 to that in 2003?
Keep it short and to the point. 0.95. What is the ratio of the Amount of exports(as % of merchandise exports) in Agricultural raw materials in 2002 to that in 2004?
Make the answer very short. 1.06. What is the ratio of the Amount of exports(as % of merchandise exports) in Food in 2002 to that in 2004?
Your answer should be very brief. 1.03. What is the ratio of the Amount of exports(as % of merchandise exports) of Fuel in 2002 to that in 2004?
Provide a short and direct response. 0.86. What is the ratio of the Amount of exports(as % of merchandise exports) in Agricultural raw materials in 2002 to that in 2005?
Give a very brief answer. 1.11. What is the ratio of the Amount of exports(as % of merchandise exports) of Food in 2002 to that in 2005?
Your answer should be very brief. 1.04. What is the ratio of the Amount of exports(as % of merchandise exports) of Fuel in 2002 to that in 2005?
Keep it short and to the point. 0.7. What is the ratio of the Amount of exports(as % of merchandise exports) of Agricultural raw materials in 2002 to that in 2006?
Give a very brief answer. 1.13. What is the ratio of the Amount of exports(as % of merchandise exports) of Food in 2002 to that in 2006?
Make the answer very short. 1.07. What is the ratio of the Amount of exports(as % of merchandise exports) of Fuel in 2002 to that in 2006?
Ensure brevity in your answer.  0.65. What is the ratio of the Amount of exports(as % of merchandise exports) of Agricultural raw materials in 2002 to that in 2007?
Your answer should be compact. 1.13. What is the ratio of the Amount of exports(as % of merchandise exports) of Food in 2002 to that in 2007?
Keep it short and to the point. 1.04. What is the ratio of the Amount of exports(as % of merchandise exports) of Fuel in 2002 to that in 2007?
Your answer should be very brief. 0.68. What is the ratio of the Amount of exports(as % of merchandise exports) of Agricultural raw materials in 2002 to that in 2008?
Keep it short and to the point. 1.22. What is the ratio of the Amount of exports(as % of merchandise exports) in Food in 2002 to that in 2008?
Provide a succinct answer. 0.98. What is the ratio of the Amount of exports(as % of merchandise exports) of Fuel in 2002 to that in 2008?
Give a very brief answer. 0.55. What is the ratio of the Amount of exports(as % of merchandise exports) of Agricultural raw materials in 2003 to that in 2004?
Give a very brief answer. 1.05. What is the ratio of the Amount of exports(as % of merchandise exports) of Food in 2003 to that in 2004?
Keep it short and to the point. 1.05. What is the ratio of the Amount of exports(as % of merchandise exports) in Fuel in 2003 to that in 2004?
Ensure brevity in your answer.  0.9. What is the ratio of the Amount of exports(as % of merchandise exports) in Agricultural raw materials in 2003 to that in 2005?
Keep it short and to the point. 1.1. What is the ratio of the Amount of exports(as % of merchandise exports) of Food in 2003 to that in 2005?
Make the answer very short. 1.05. What is the ratio of the Amount of exports(as % of merchandise exports) in Fuel in 2003 to that in 2005?
Provide a short and direct response. 0.74. What is the ratio of the Amount of exports(as % of merchandise exports) of Agricultural raw materials in 2003 to that in 2006?
Provide a short and direct response. 1.12. What is the ratio of the Amount of exports(as % of merchandise exports) in Food in 2003 to that in 2006?
Provide a succinct answer. 1.08. What is the ratio of the Amount of exports(as % of merchandise exports) in Fuel in 2003 to that in 2006?
Give a very brief answer. 0.68. What is the ratio of the Amount of exports(as % of merchandise exports) of Agricultural raw materials in 2003 to that in 2007?
Your answer should be compact. 1.12. What is the ratio of the Amount of exports(as % of merchandise exports) of Food in 2003 to that in 2007?
Your answer should be compact. 1.05. What is the ratio of the Amount of exports(as % of merchandise exports) in Fuel in 2003 to that in 2007?
Offer a very short reply. 0.72. What is the ratio of the Amount of exports(as % of merchandise exports) in Agricultural raw materials in 2003 to that in 2008?
Your answer should be very brief. 1.21. What is the ratio of the Amount of exports(as % of merchandise exports) of Agricultural raw materials in 2004 to that in 2005?
Your answer should be very brief. 1.05. What is the ratio of the Amount of exports(as % of merchandise exports) in Food in 2004 to that in 2005?
Your answer should be compact. 1.01. What is the ratio of the Amount of exports(as % of merchandise exports) in Fuel in 2004 to that in 2005?
Give a very brief answer. 0.82. What is the ratio of the Amount of exports(as % of merchandise exports) in Agricultural raw materials in 2004 to that in 2006?
Provide a succinct answer. 1.06. What is the ratio of the Amount of exports(as % of merchandise exports) of Food in 2004 to that in 2006?
Your answer should be compact. 1.04. What is the ratio of the Amount of exports(as % of merchandise exports) of Fuel in 2004 to that in 2006?
Make the answer very short. 0.76. What is the ratio of the Amount of exports(as % of merchandise exports) of Agricultural raw materials in 2004 to that in 2007?
Provide a succinct answer. 1.07. What is the ratio of the Amount of exports(as % of merchandise exports) of Food in 2004 to that in 2007?
Provide a short and direct response. 1.01. What is the ratio of the Amount of exports(as % of merchandise exports) in Fuel in 2004 to that in 2007?
Your answer should be very brief. 0.8. What is the ratio of the Amount of exports(as % of merchandise exports) of Agricultural raw materials in 2004 to that in 2008?
Your answer should be very brief. 1.15. What is the ratio of the Amount of exports(as % of merchandise exports) in Food in 2004 to that in 2008?
Keep it short and to the point. 0.95. What is the ratio of the Amount of exports(as % of merchandise exports) of Fuel in 2004 to that in 2008?
Keep it short and to the point. 0.64. What is the ratio of the Amount of exports(as % of merchandise exports) in Agricultural raw materials in 2005 to that in 2006?
Provide a short and direct response. 1.02. What is the ratio of the Amount of exports(as % of merchandise exports) in Food in 2005 to that in 2006?
Give a very brief answer. 1.03. What is the ratio of the Amount of exports(as % of merchandise exports) of Fuel in 2005 to that in 2006?
Offer a terse response. 0.92. What is the ratio of the Amount of exports(as % of merchandise exports) of Agricultural raw materials in 2005 to that in 2007?
Your response must be concise. 1.02. What is the ratio of the Amount of exports(as % of merchandise exports) of Food in 2005 to that in 2007?
Give a very brief answer. 1. What is the ratio of the Amount of exports(as % of merchandise exports) of Fuel in 2005 to that in 2007?
Your answer should be compact. 0.97. What is the ratio of the Amount of exports(as % of merchandise exports) in Agricultural raw materials in 2005 to that in 2008?
Provide a short and direct response. 1.1. What is the ratio of the Amount of exports(as % of merchandise exports) in Food in 2005 to that in 2008?
Ensure brevity in your answer.  0.95. What is the ratio of the Amount of exports(as % of merchandise exports) of Fuel in 2005 to that in 2008?
Provide a short and direct response. 0.78. What is the ratio of the Amount of exports(as % of merchandise exports) of Agricultural raw materials in 2006 to that in 2007?
Provide a short and direct response. 1. What is the ratio of the Amount of exports(as % of merchandise exports) in Food in 2006 to that in 2007?
Ensure brevity in your answer.  0.97. What is the ratio of the Amount of exports(as % of merchandise exports) of Fuel in 2006 to that in 2007?
Provide a short and direct response. 1.05. What is the ratio of the Amount of exports(as % of merchandise exports) in Agricultural raw materials in 2006 to that in 2008?
Your response must be concise. 1.08. What is the ratio of the Amount of exports(as % of merchandise exports) of Food in 2006 to that in 2008?
Your response must be concise. 0.92. What is the ratio of the Amount of exports(as % of merchandise exports) in Fuel in 2006 to that in 2008?
Provide a succinct answer. 0.84. What is the ratio of the Amount of exports(as % of merchandise exports) of Agricultural raw materials in 2007 to that in 2008?
Ensure brevity in your answer.  1.08. What is the ratio of the Amount of exports(as % of merchandise exports) of Food in 2007 to that in 2008?
Your answer should be compact. 0.95. What is the ratio of the Amount of exports(as % of merchandise exports) of Fuel in 2007 to that in 2008?
Provide a short and direct response. 0.8. What is the difference between the highest and the second highest Amount of exports(as % of merchandise exports) in Agricultural raw materials?
Offer a very short reply. 0.01. What is the difference between the highest and the second highest Amount of exports(as % of merchandise exports) in Food?
Make the answer very short. 0.01. What is the difference between the highest and the second highest Amount of exports(as % of merchandise exports) in Fuel?
Make the answer very short. 0.99. What is the difference between the highest and the lowest Amount of exports(as % of merchandise exports) in Agricultural raw materials?
Make the answer very short. 0.27. What is the difference between the highest and the lowest Amount of exports(as % of merchandise exports) of Food?
Your answer should be compact. 0.64. What is the difference between the highest and the lowest Amount of exports(as % of merchandise exports) in Fuel?
Your answer should be very brief. 2.84. 